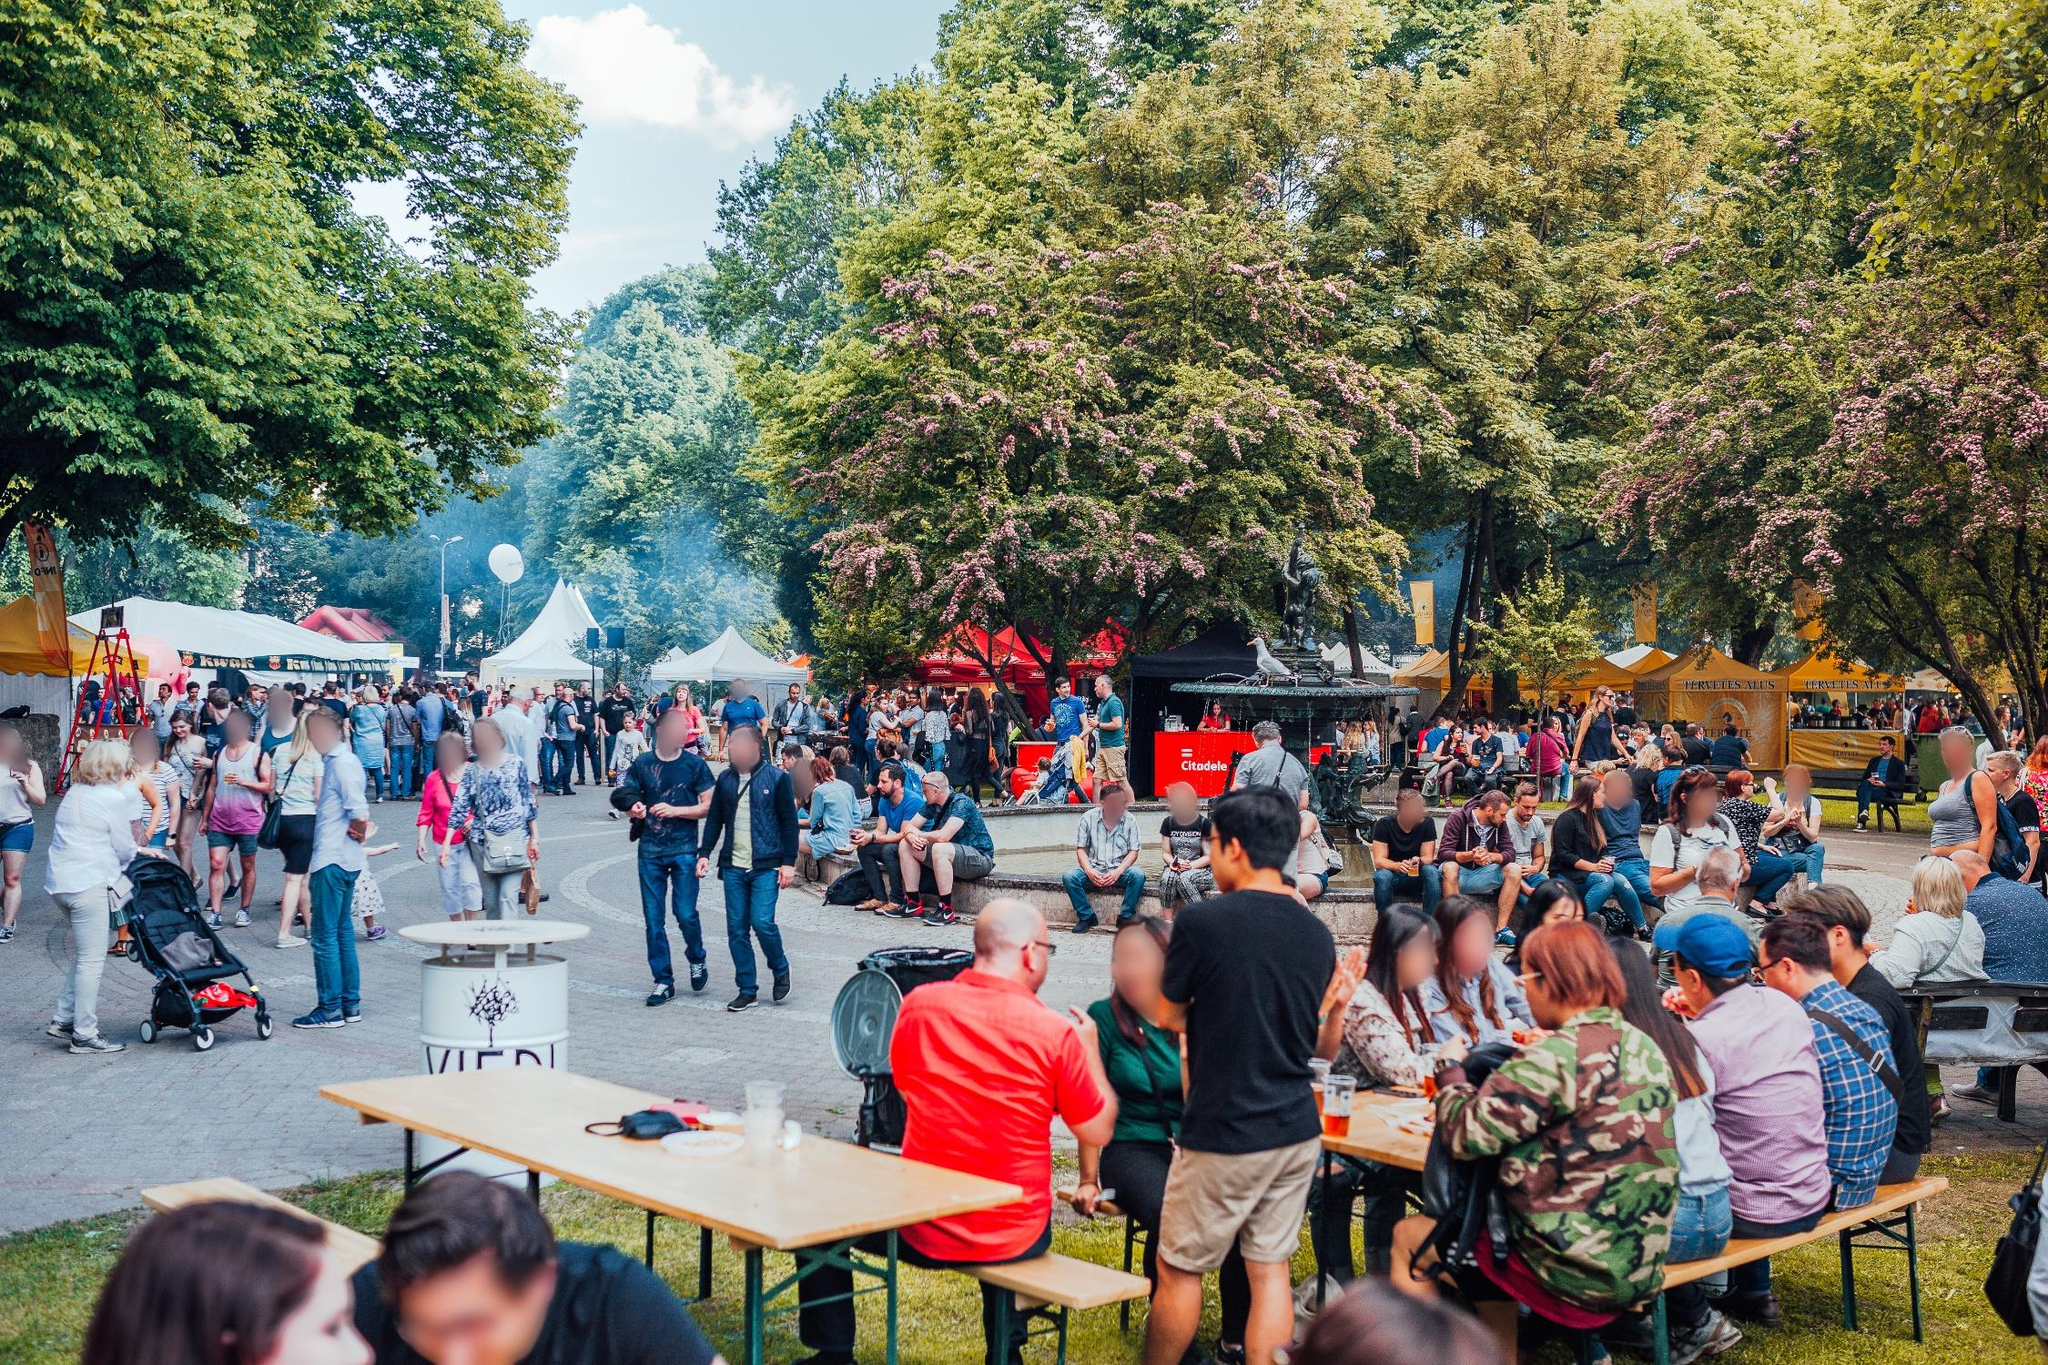What kinds of food might be available at the festival based on the image? The presence of various tents and notably a red food truck suggests a diverse food selection. Likely offerings include street food, snacks like pretzels or popcorn, and possibly international cuisine given the apparent diversity of the crowd. The food truck might offer fast, hearty meals perfect for outdoor enjoyment. 